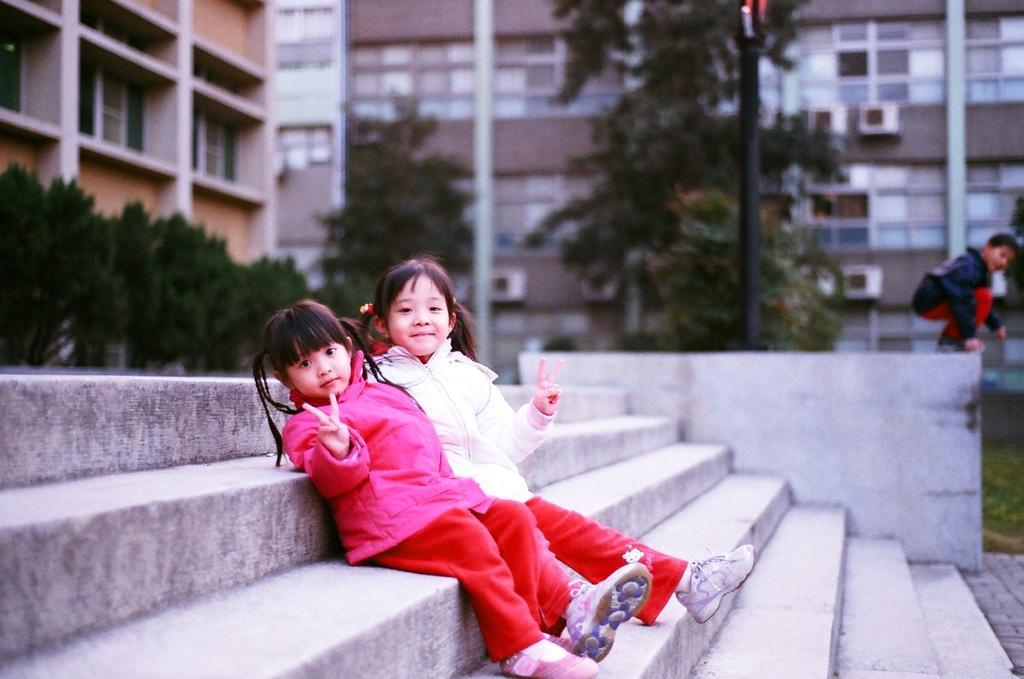Could you give a brief overview of what you see in this image? In this image I can see three people with different color dresses. I can see two people are sitting on the stairs. In the background I can see poles, many trees and the buildings. 